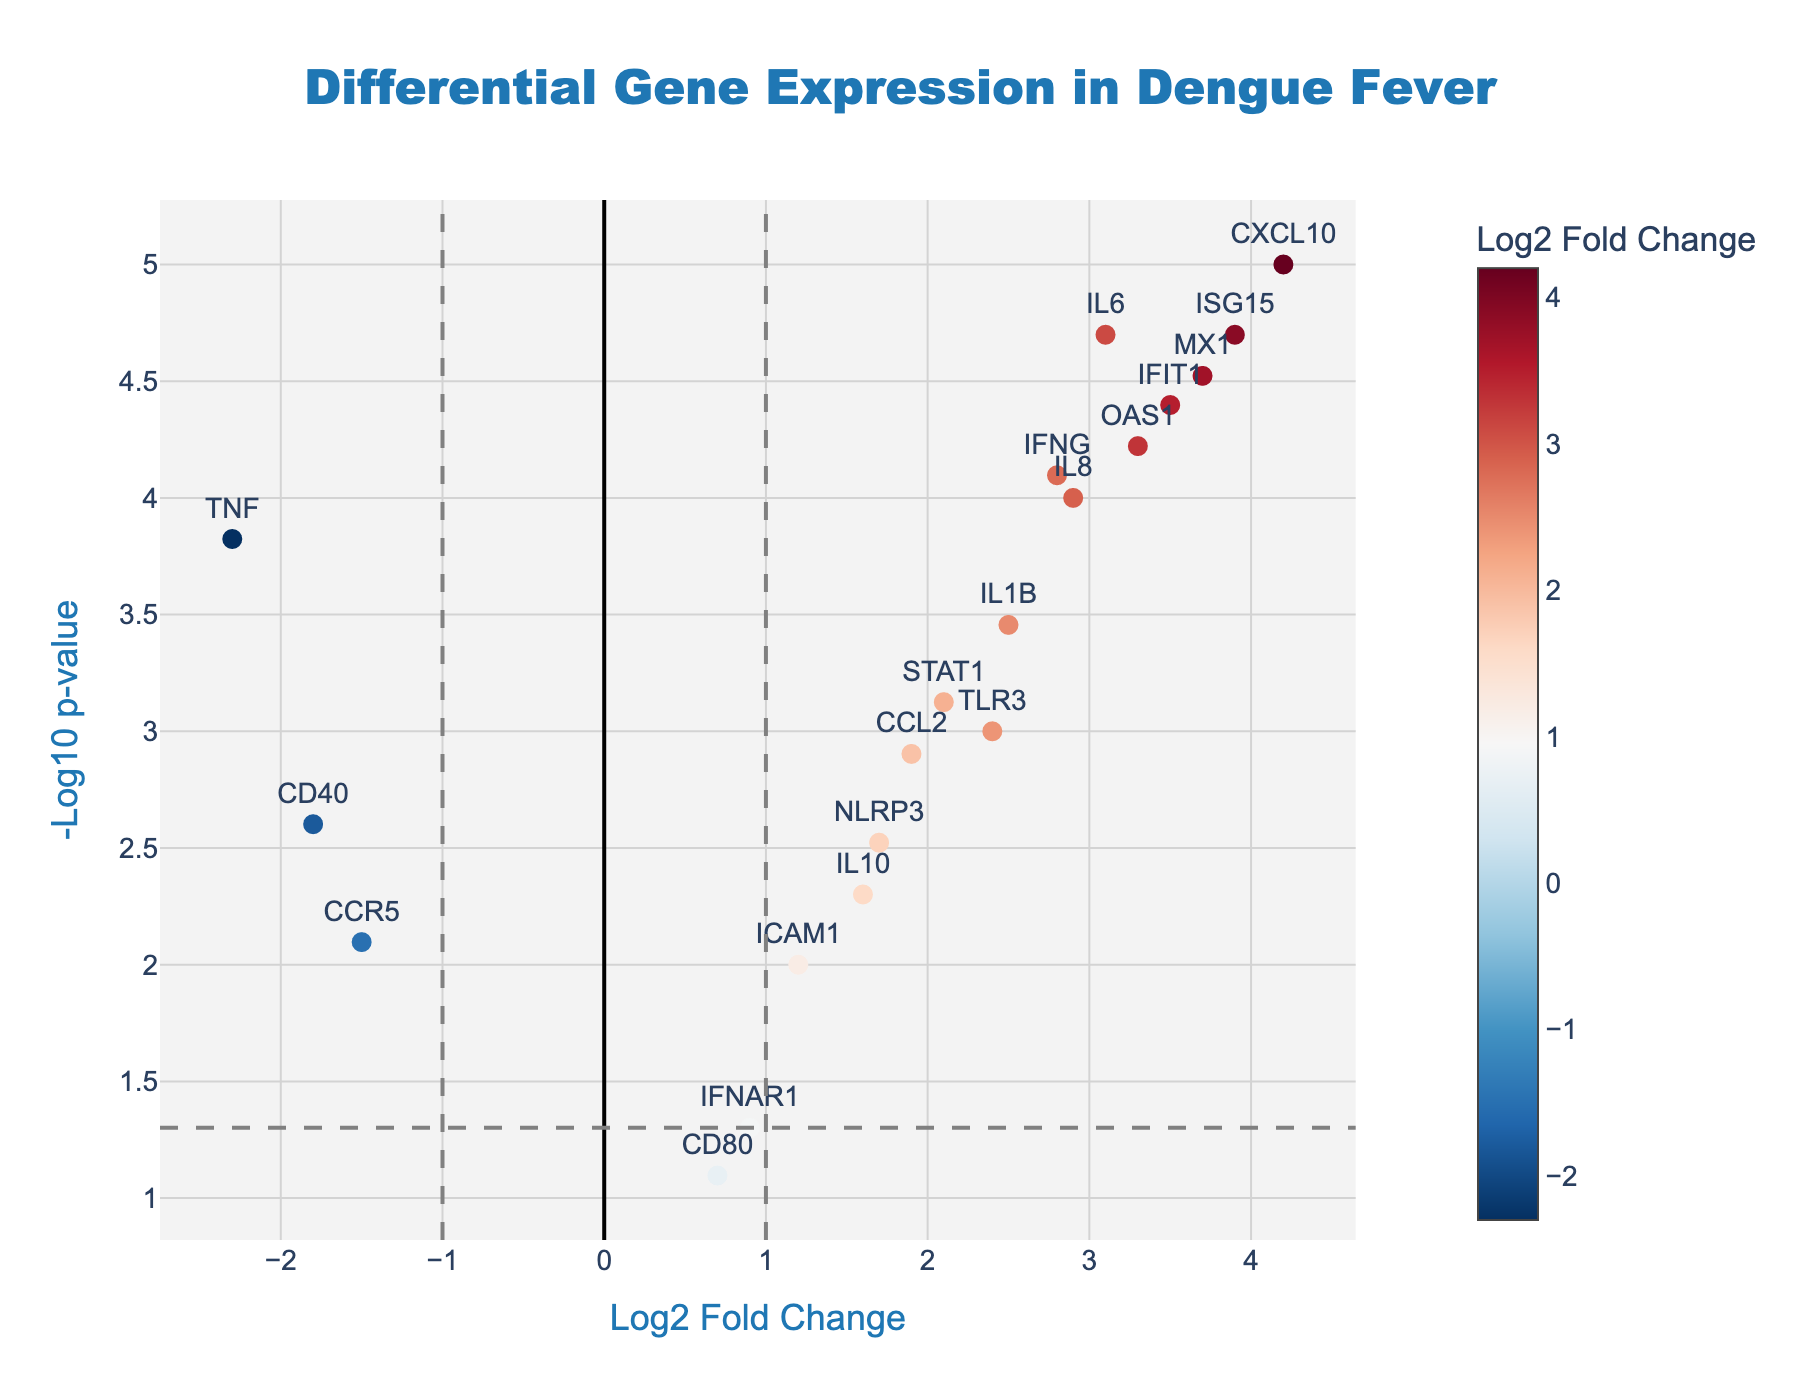What's the title of the plot? The title of the plot is located at the top and is often highlighted. In this case, it reads "Differential Gene Expression in Dengue Fever".
Answer: Differential Gene Expression in Dengue Fever How many genes have a log2 fold change greater than 3? To find the number of genes with a log2 fold change greater than 3, count the points that lie to the right of the 3 on the x-axis. There are four such genes: IL6, CXCL10, MX1, and ISG15.
Answer: 4 Which gene has the highest -log10 p-value? The highest -log10 p-value is represented by the point that lies the farthest up on the y-axis. CXCL10 is the gene with the highest -log10 p-value.
Answer: CXCL10 Are there any genes with a p-value less than 0.05 and a log2 fold change between -1 and 1? First, identify the range between -1 and 1 on the x-axis. Next, check if any -log10 p-value points within this range on the x-axis are above the threshold line drawn for -log10(0.05). The genes that fit this criteria are IFNAR1 and CD80.
Answer: 2, IFNAR1 and CD80 Which gene shows the most significant decrease in expression? A decrease in expression is represented by a negative log2 fold change. The most significant decrease in expression is indicated by the gene with the lowest log2 fold change value. In this case, it is TNF with a log2 fold change of -2.3.
Answer: TNF How many genes have a log2 fold change of less than -1 and a p-value less than 0.05? To find this, check the left side of the plot where the log2 fold change is less than -1, and see how many points are above the horizontal line representing -log10(0.05). There are two such genes: TNF and CD40.
Answer: 2, TNF and CD40 What is the approximate p-value for the gene IFNAR1? Locate the gene IFNAR1 on the plot and check its vertical position. It is close to the horizontal threshold line representing -log10(0.05). Taking the inverse log transform of -log10(0.05) gives a p-value of approximately 0.05.
Answer: ~0.05 Which gene has the largest fold change but is not statistically significant at p < 0.05? "Not statistically significant at p < 0.05" means the point is below the horizontal threshold line. For the largest fold change, look at the x-axis farthest points. CD80 has a log2 fold change of 0.7 and a p-value not below 0.05.
Answer: CD80 How many genes are upregulated with statistical significance (p < 0.05)? Upregulated genes have positive log2 fold change, and statistical significance is indicated by points above the threshold line. Count the number of such points on the right side of the x-axis: IL6, IFNG, CCL2, CXCL10, IL1B, MX1, OAS1, ISG15, STAT1, IFIT1, TLR3, NLRP3, and IL8.
Answer: 13 What is the log2 fold change for the gene IL10? Locate the gene IL10 on the plot by its label and hover text and then check the x-axis value where it lies. The log2 fold change for IL10 is 1.6.
Answer: 1.6 